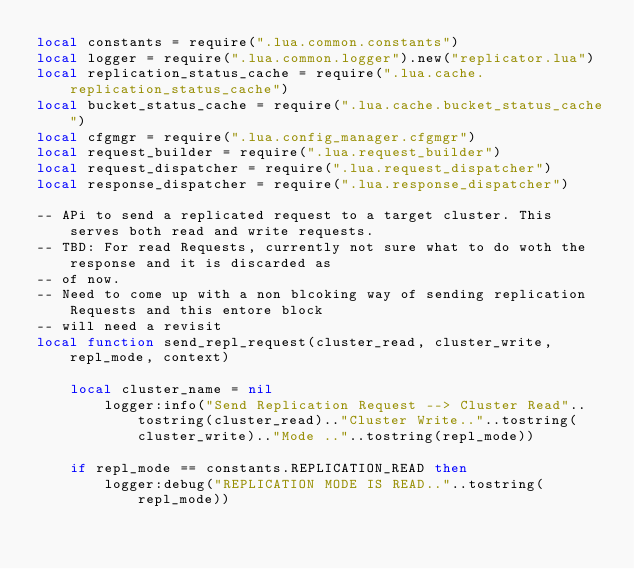Convert code to text. <code><loc_0><loc_0><loc_500><loc_500><_Lua_>local constants = require(".lua.common.constants")
local logger = require(".lua.common.logger").new("replicator.lua")
local replication_status_cache = require(".lua.cache.replication_status_cache")
local bucket_status_cache = require(".lua.cache.bucket_status_cache")
local cfgmgr = require(".lua.config_manager.cfgmgr")
local request_builder = require(".lua.request_builder")
local request_dispatcher = require(".lua.request_dispatcher")
local response_dispatcher = require(".lua.response_dispatcher")

-- APi to send a replicated request to a target cluster. This serves both read and write requests.
-- TBD: For read Requests, currently not sure what to do woth the response and it is discarded as
-- of now. 
-- Need to come up with a non blcoking way of sending replication Requests and this entore block
-- will need a revisit
local function send_repl_request(cluster_read, cluster_write, repl_mode, context)

	local cluster_name = nil
        logger:info("Send Replication Request --> Cluster Read"..tostring(cluster_read).."Cluster Write.."..tostring(cluster_write).."Mode .."..tostring(repl_mode))
	
	if repl_mode == constants.REPLICATION_READ then 
		logger:debug("REPLICATION MODE IS READ.."..tostring(repl_mode))
		</code> 